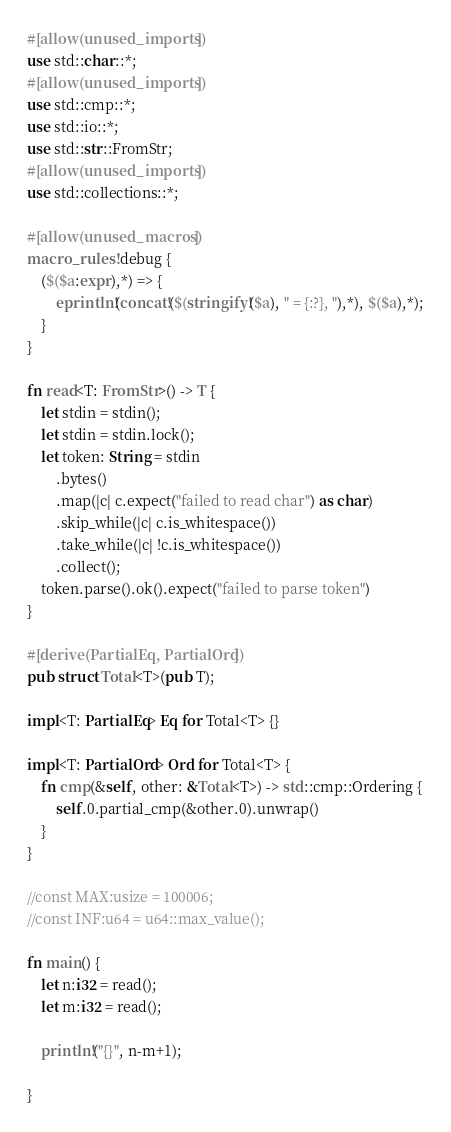<code> <loc_0><loc_0><loc_500><loc_500><_Rust_>#[allow(unused_imports)]
use std::char::*;
#[allow(unused_imports)]
use std::cmp::*;
use std::io::*;
use std::str::FromStr;
#[allow(unused_imports)]
use std::collections::*;

#[allow(unused_macros)]
macro_rules! debug {
    ($($a:expr),*) => {
        eprintln!(concat!($(stringify!($a), " = {:?}, "),*), $($a),*);
    }
}

fn read<T: FromStr>() -> T {
    let stdin = stdin();
    let stdin = stdin.lock();
    let token: String = stdin
        .bytes()
        .map(|c| c.expect("failed to read char") as char)
        .skip_while(|c| c.is_whitespace())
        .take_while(|c| !c.is_whitespace())
        .collect();
    token.parse().ok().expect("failed to parse token")
}

#[derive(PartialEq, PartialOrd)]
pub struct Total<T>(pub T);

impl<T: PartialEq> Eq for Total<T> {}

impl<T: PartialOrd> Ord for Total<T> {
    fn cmp(&self, other: &Total<T>) -> std::cmp::Ordering {
        self.0.partial_cmp(&other.0).unwrap()
    }
}

//const MAX:usize = 100006;
//const INF:u64 = u64::max_value();

fn main() {
    let n:i32 = read();
    let m:i32 = read();

    println!("{}", n-m+1);
    
}
</code> 